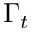<formula> <loc_0><loc_0><loc_500><loc_500>\Gamma _ { t }</formula> 